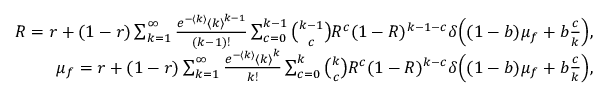<formula> <loc_0><loc_0><loc_500><loc_500>\begin{array} { r } { R = r + ( 1 - r ) \sum _ { k = 1 } ^ { \infty } \frac { e ^ { - \langle k \rangle } { \langle k \rangle } ^ { k - 1 } } { ( k - 1 ) ! } \sum _ { c = 0 } ^ { k - 1 } \binom { k - 1 } { c } R ^ { c } ( 1 - R ) ^ { k - 1 - c } \delta \left ( ( 1 - b ) \mu _ { f } + b \frac { c } { k } \right ) , } \\ { \mu _ { f } = r + ( 1 - r ) \sum _ { k = 1 } ^ { \infty } \frac { e ^ { - \langle k \rangle } { \langle k \rangle } ^ { k } } { k ! } \sum _ { c = 0 } ^ { k } \binom { k } { c } R ^ { c } ( 1 - R ) ^ { k - c } \delta \left ( ( 1 - b ) \mu _ { f } + b \frac { c } { k } \right ) , } \end{array}</formula> 